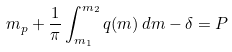<formula> <loc_0><loc_0><loc_500><loc_500>m _ { p } + \frac { 1 } { \pi } \int _ { m _ { 1 } } ^ { m _ { 2 } } q ( m ) \, d m - \delta = P</formula> 